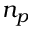Convert formula to latex. <formula><loc_0><loc_0><loc_500><loc_500>n _ { p }</formula> 